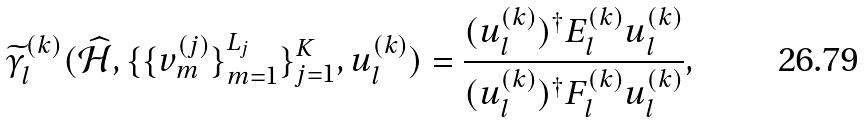<formula> <loc_0><loc_0><loc_500><loc_500>\widetilde { \gamma } _ { l } ^ { ( k ) } ( \widehat { \mathcal { H } } , \{ \{ v _ { m } ^ { ( j ) } \} _ { m = 1 } ^ { L _ { j } } \} _ { j = 1 } ^ { K } , u _ { l } ^ { ( k ) } ) = \frac { ( u _ { l } ^ { ( k ) } ) ^ { \dag } E _ { l } ^ { ( k ) } u _ { l } ^ { ( k ) } } { ( u _ { l } ^ { ( k ) } ) ^ { \dag } F _ { l } ^ { ( k ) } u _ { l } ^ { ( k ) } } ,</formula> 